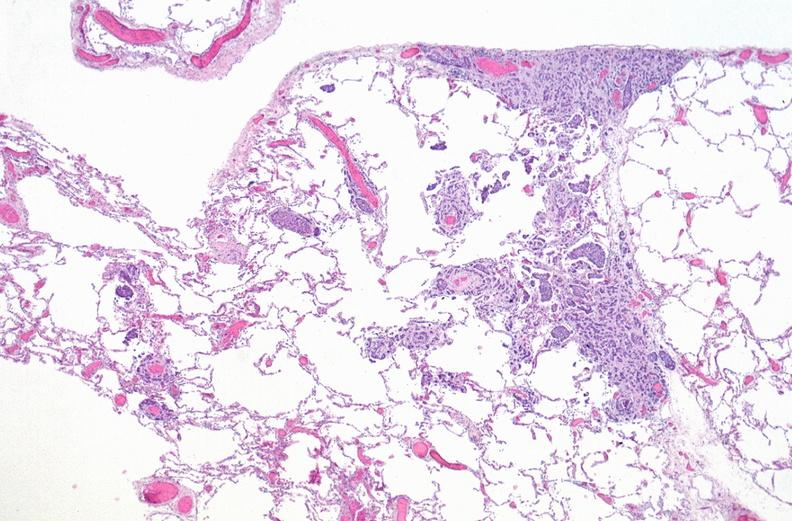where is this?
Answer the question using a single word or phrase. Lung 